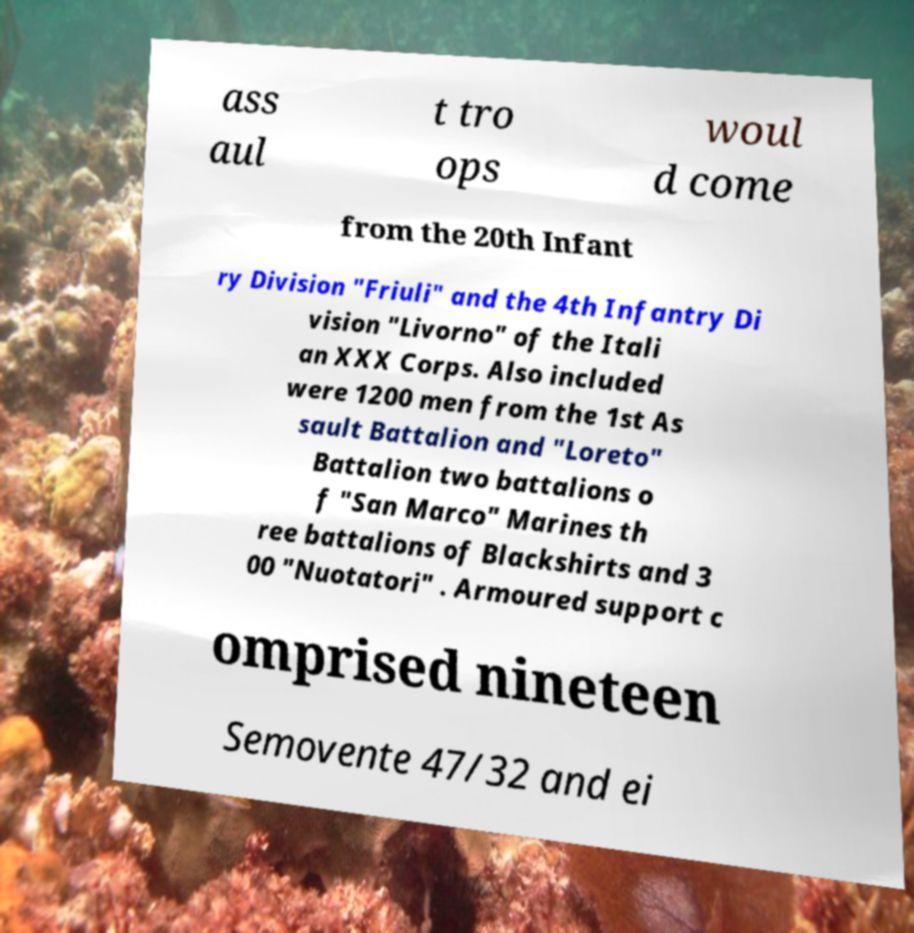Can you accurately transcribe the text from the provided image for me? ass aul t tro ops woul d come from the 20th Infant ry Division "Friuli" and the 4th Infantry Di vision "Livorno" of the Itali an XXX Corps. Also included were 1200 men from the 1st As sault Battalion and "Loreto" Battalion two battalions o f "San Marco" Marines th ree battalions of Blackshirts and 3 00 "Nuotatori" . Armoured support c omprised nineteen Semovente 47/32 and ei 